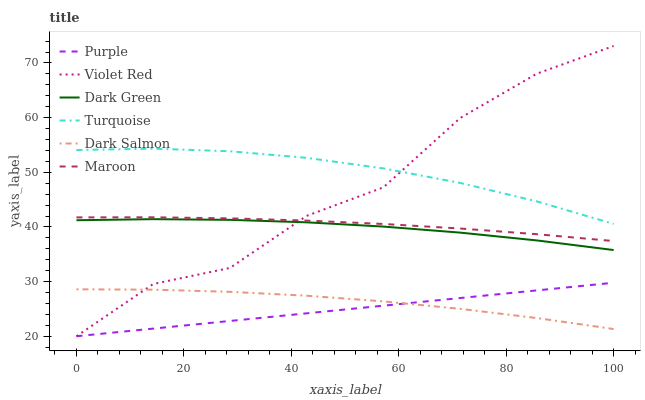Does Purple have the minimum area under the curve?
Answer yes or no. Yes. Does Turquoise have the maximum area under the curve?
Answer yes or no. Yes. Does Dark Salmon have the minimum area under the curve?
Answer yes or no. No. Does Dark Salmon have the maximum area under the curve?
Answer yes or no. No. Is Purple the smoothest?
Answer yes or no. Yes. Is Violet Red the roughest?
Answer yes or no. Yes. Is Dark Salmon the smoothest?
Answer yes or no. No. Is Dark Salmon the roughest?
Answer yes or no. No. Does Violet Red have the lowest value?
Answer yes or no. Yes. Does Dark Salmon have the lowest value?
Answer yes or no. No. Does Violet Red have the highest value?
Answer yes or no. Yes. Does Purple have the highest value?
Answer yes or no. No. Is Purple less than Dark Green?
Answer yes or no. Yes. Is Maroon greater than Purple?
Answer yes or no. Yes. Does Violet Red intersect Purple?
Answer yes or no. Yes. Is Violet Red less than Purple?
Answer yes or no. No. Is Violet Red greater than Purple?
Answer yes or no. No. Does Purple intersect Dark Green?
Answer yes or no. No. 